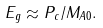<formula> <loc_0><loc_0><loc_500><loc_500>E _ { g } \approx P _ { c } / M _ { A 0 } .</formula> 